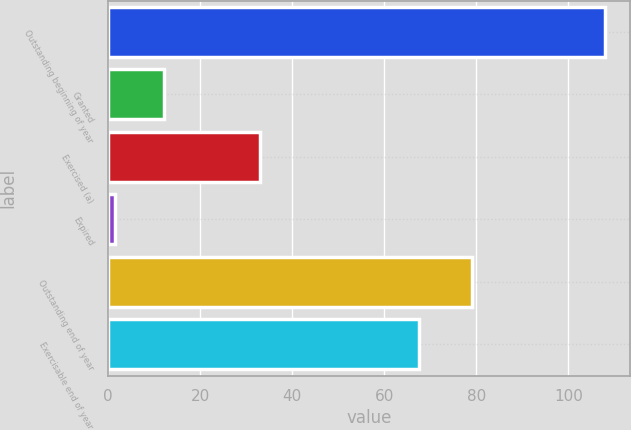Convert chart to OTSL. <chart><loc_0><loc_0><loc_500><loc_500><bar_chart><fcel>Outstanding beginning of year<fcel>Granted<fcel>Exercised (a)<fcel>Expired<fcel>Outstanding end of year<fcel>Exercisable end of year<nl><fcel>108<fcel>12.24<fcel>33.1<fcel>1.6<fcel>79.1<fcel>67.6<nl></chart> 